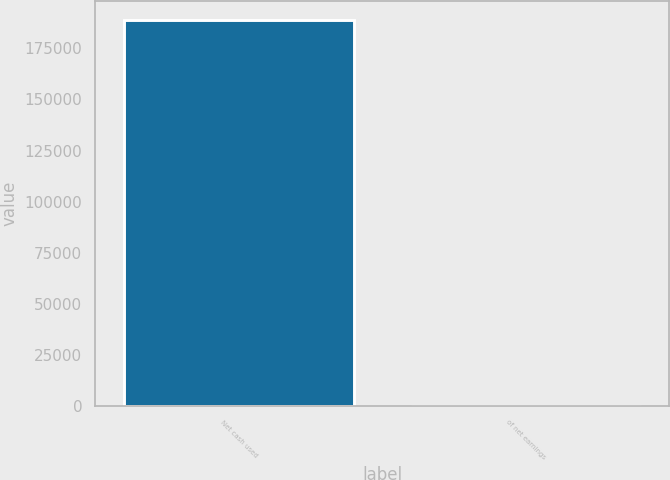Convert chart to OTSL. <chart><loc_0><loc_0><loc_500><loc_500><bar_chart><fcel>Net cash used<fcel>of net earnings<nl><fcel>188781<fcel>38.2<nl></chart> 